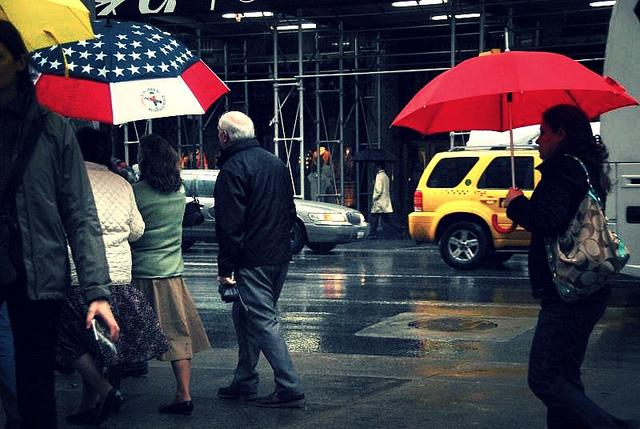One of the umbrellas is inspired by which country's flag?

Choices:
A) morocco
B) germany
C) usa
D) denmark usa 